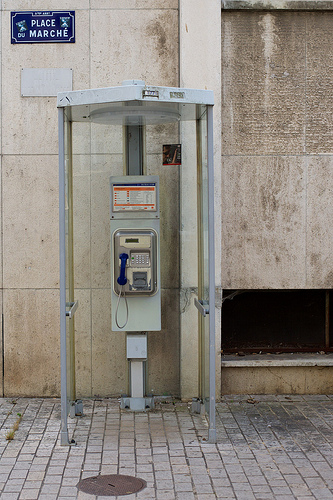<image>
Is the sign behind the phone? No. The sign is not behind the phone. From this viewpoint, the sign appears to be positioned elsewhere in the scene. 